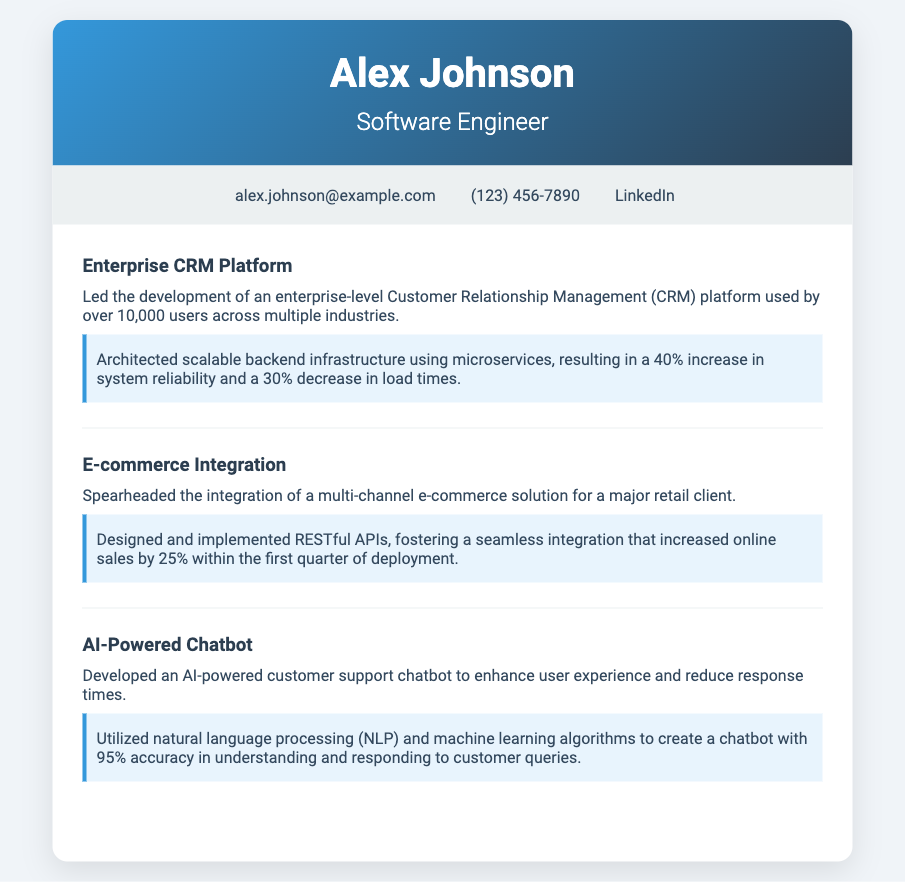what position does Alex Johnson hold? Alex Johnson is identified as a Software Engineer in the document.
Answer: Software Engineer how many users does the CRM platform support? The document states that the enterprise-level CRM platform is used by over 10,000 users.
Answer: 10,000 what was the increase in system reliability due to the backend infrastructure? The backend infrastructure resulted in a 40% increase in system reliability.
Answer: 40% what percentage did online sales increase after the e-commerce solution deployment? The integration of the e-commerce solution increased online sales by 25%.
Answer: 25% what technology was utilized to develop the AI-powered chatbot? The AI-powered customer support chatbot was developed using natural language processing and machine learning algorithms.
Answer: natural language processing and machine learning algorithms who was the major retail client mentioned in the e-commerce integration highlight? The document does not specify the name of the major retail client involved in the e-commerce integration.
Answer: Not specified what is the accuracy percentage of the AI-powered chatbot in understanding queries? The accuracy of the chatbot in understanding queries is stated as 95%.
Answer: 95% how many key projects are highlighted in the document? There are three key projects highlighted in the document: the CRM platform, e-commerce integration, and AI-powered chatbot.
Answer: three what formatting style is used for the contributions in the highlights? Each contribution in the highlights is presented with a background color of light blue and a border on the left.
Answer: light blue background with a left border 